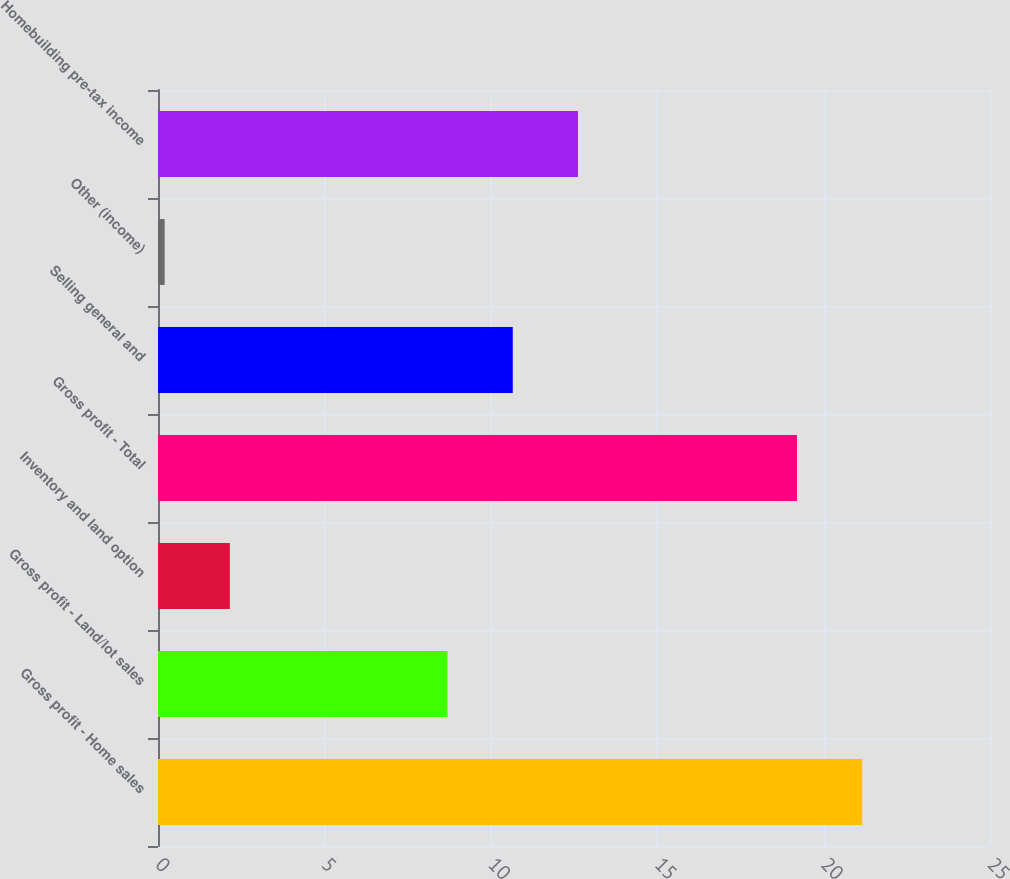Convert chart to OTSL. <chart><loc_0><loc_0><loc_500><loc_500><bar_chart><fcel>Gross profit - Home sales<fcel>Gross profit - Land/lot sales<fcel>Inventory and land option<fcel>Gross profit - Total<fcel>Selling general and<fcel>Other (income)<fcel>Homebuilding pre-tax income<nl><fcel>21.16<fcel>8.7<fcel>2.16<fcel>19.2<fcel>10.66<fcel>0.2<fcel>12.62<nl></chart> 